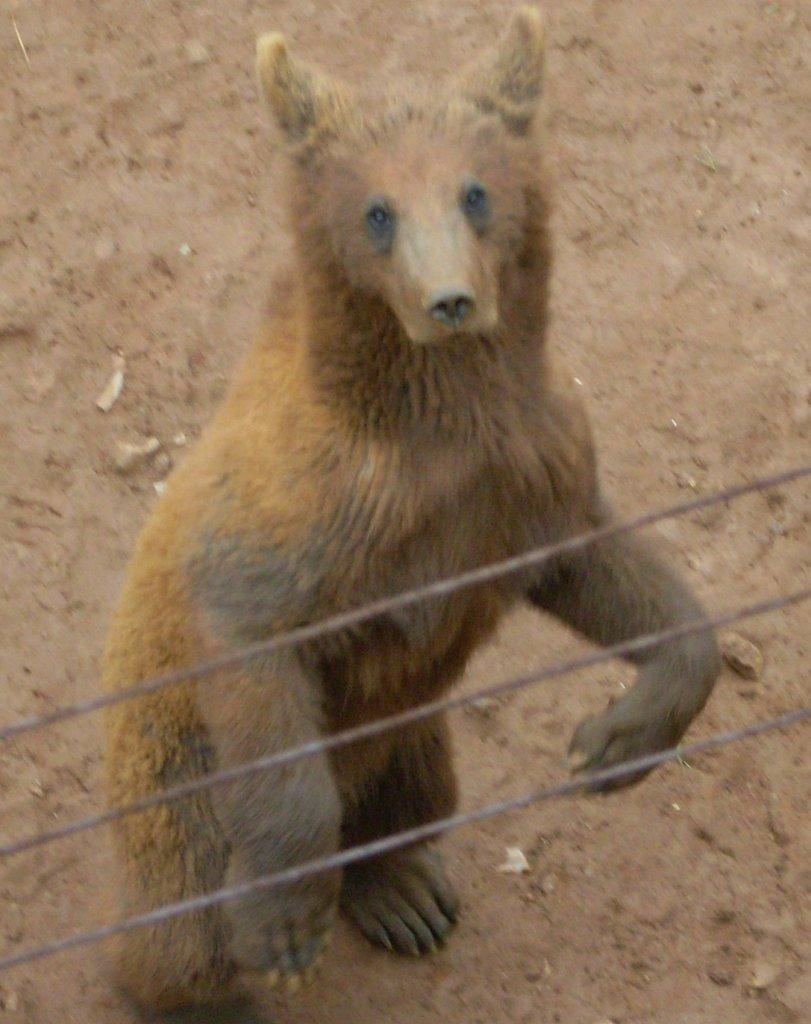What type of animal is in the image? There is an animal in the image, but the specific type cannot be determined from the provided facts. How many wires are present in the image? There are three wires in the image. What can be seen in the background of the image? The ground is visible in the background of the image. Who is the owner of the car that the animal is driving in the image? There is no car or driving depicted in the image, so it is not possible to determine the owner of a car. 